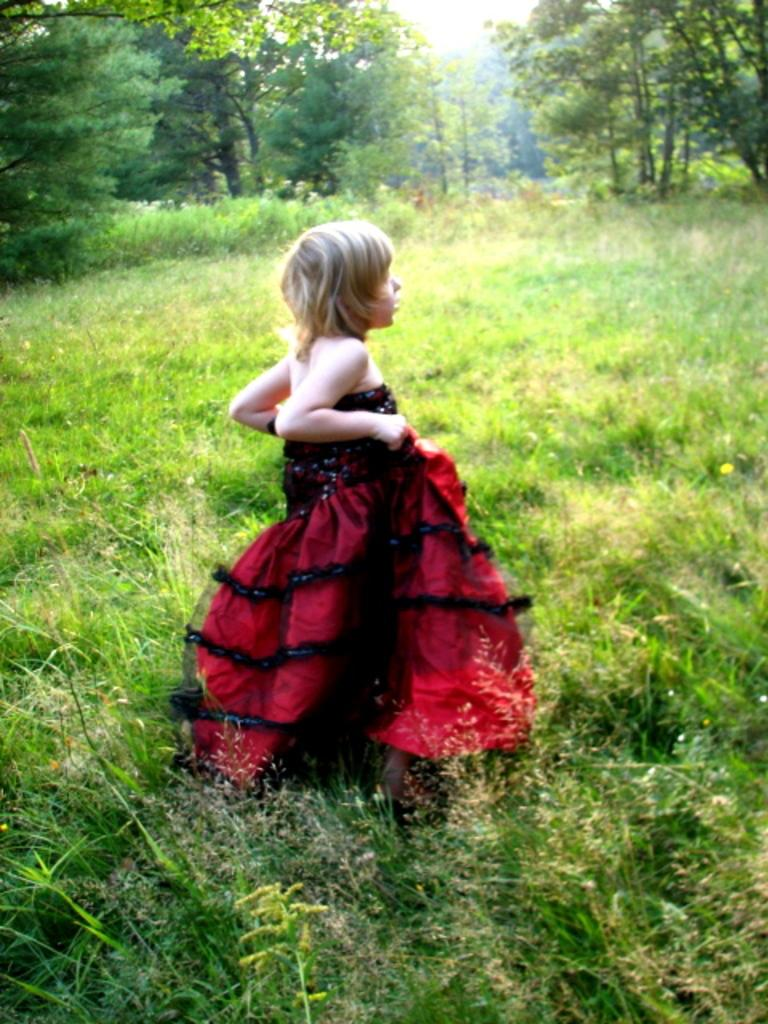Who is the main subject in the image? There is a girl in the image. What is the girl wearing? The girl is wearing a red dress. Where is the girl standing? The girl is standing on a path. What can be seen behind the girl? There are trees and plants behind the girl. What type of kettle is the girl holding in the image? There is no kettle present in the image; the girl is not holding anything. 